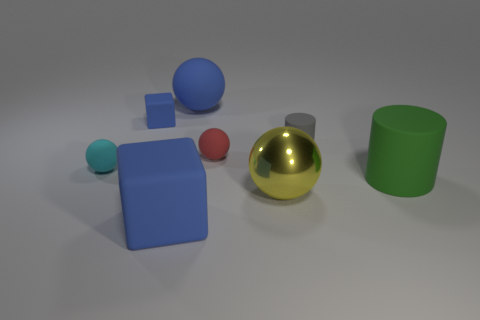There is a blue object that is the same shape as the small red matte thing; what is its size?
Your answer should be very brief. Large. There is a cyan matte ball; is its size the same as the blue cube that is behind the large metallic ball?
Offer a terse response. Yes. What number of metal things are large blue objects or blue things?
Make the answer very short. 0. Are there more big green cylinders than tiny gray shiny objects?
Your answer should be very brief. Yes. There is another matte cube that is the same color as the large matte block; what size is it?
Your answer should be very brief. Small. There is a big matte thing to the right of the large blue rubber thing that is behind the cyan rubber ball; what shape is it?
Offer a very short reply. Cylinder. There is a gray cylinder behind the large object that is to the right of the yellow metallic thing; are there any large blue rubber things to the right of it?
Your answer should be very brief. No. There is a cylinder that is the same size as the yellow metallic object; what color is it?
Provide a short and direct response. Green. There is a blue thing that is behind the large rubber cylinder and on the right side of the tiny blue matte block; what shape is it?
Give a very brief answer. Sphere. There is a blue rubber cube in front of the tiny rubber sphere that is to the left of the tiny red sphere; how big is it?
Offer a very short reply. Large. 